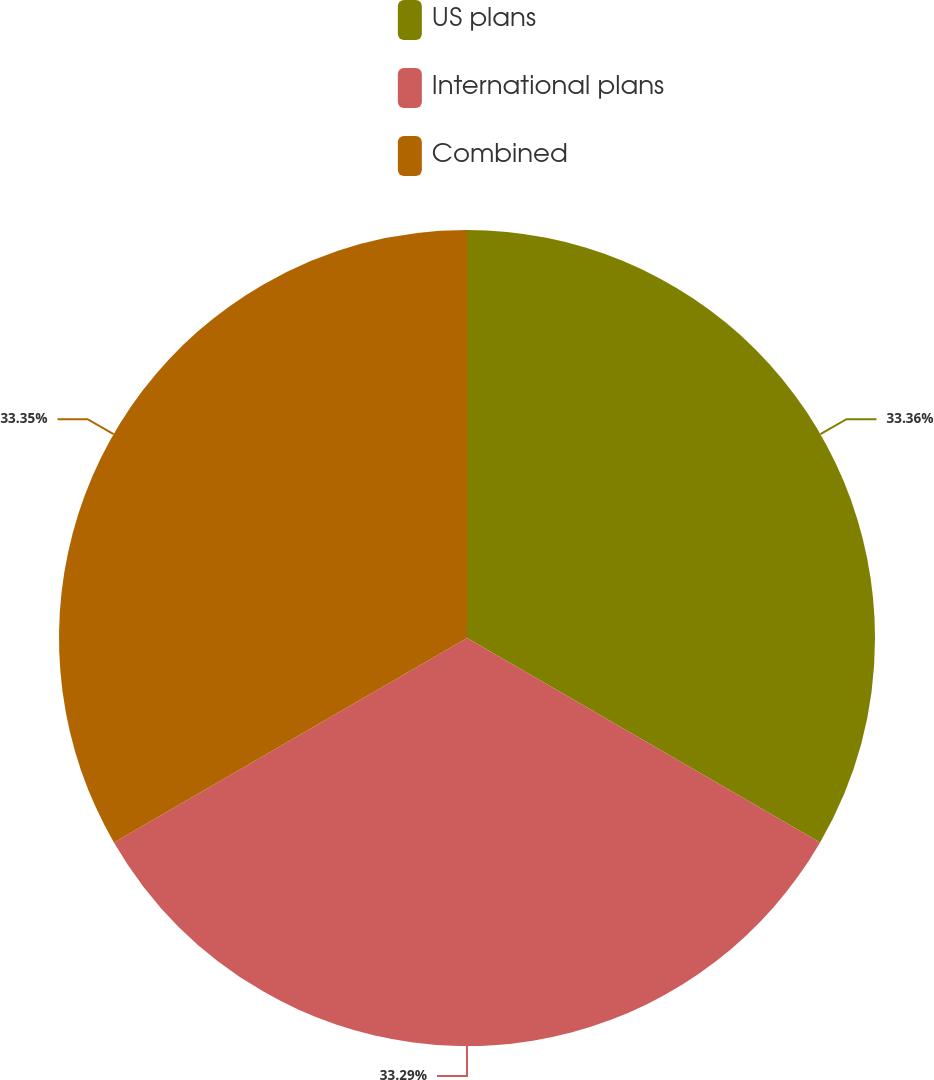Convert chart. <chart><loc_0><loc_0><loc_500><loc_500><pie_chart><fcel>US plans<fcel>International plans<fcel>Combined<nl><fcel>33.35%<fcel>33.29%<fcel>33.35%<nl></chart> 